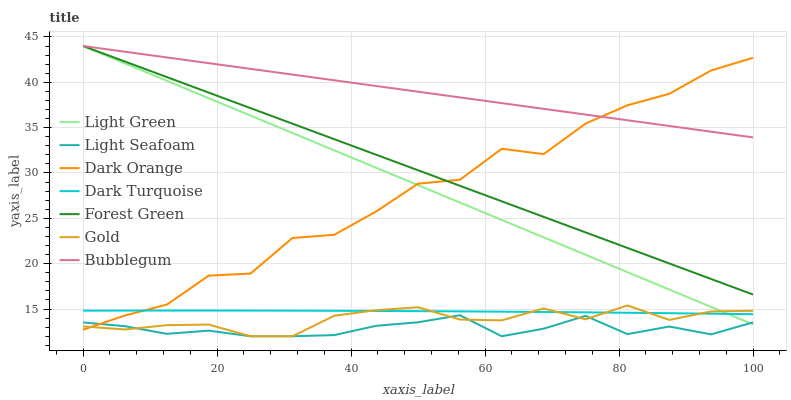Does Light Seafoam have the minimum area under the curve?
Answer yes or no. Yes. Does Bubblegum have the maximum area under the curve?
Answer yes or no. Yes. Does Gold have the minimum area under the curve?
Answer yes or no. No. Does Gold have the maximum area under the curve?
Answer yes or no. No. Is Forest Green the smoothest?
Answer yes or no. Yes. Is Dark Orange the roughest?
Answer yes or no. Yes. Is Gold the smoothest?
Answer yes or no. No. Is Gold the roughest?
Answer yes or no. No. Does Gold have the lowest value?
Answer yes or no. Yes. Does Dark Turquoise have the lowest value?
Answer yes or no. No. Does Light Green have the highest value?
Answer yes or no. Yes. Does Gold have the highest value?
Answer yes or no. No. Is Gold less than Forest Green?
Answer yes or no. Yes. Is Bubblegum greater than Light Seafoam?
Answer yes or no. Yes. Does Light Green intersect Light Seafoam?
Answer yes or no. Yes. Is Light Green less than Light Seafoam?
Answer yes or no. No. Is Light Green greater than Light Seafoam?
Answer yes or no. No. Does Gold intersect Forest Green?
Answer yes or no. No. 